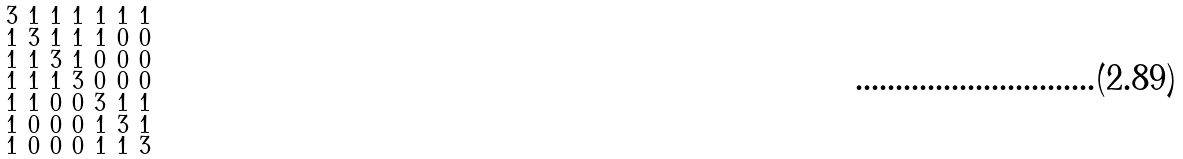Convert formula to latex. <formula><loc_0><loc_0><loc_500><loc_500>\begin{smallmatrix} 3 & 1 & 1 & 1 & 1 & 1 & 1 \\ 1 & 3 & 1 & 1 & 1 & 0 & 0 \\ 1 & 1 & 3 & 1 & 0 & 0 & 0 \\ 1 & 1 & 1 & 3 & 0 & 0 & 0 \\ 1 & 1 & 0 & 0 & 3 & 1 & 1 \\ 1 & 0 & 0 & 0 & 1 & 3 & 1 \\ 1 & 0 & 0 & 0 & 1 & 1 & 3 \end{smallmatrix}</formula> 